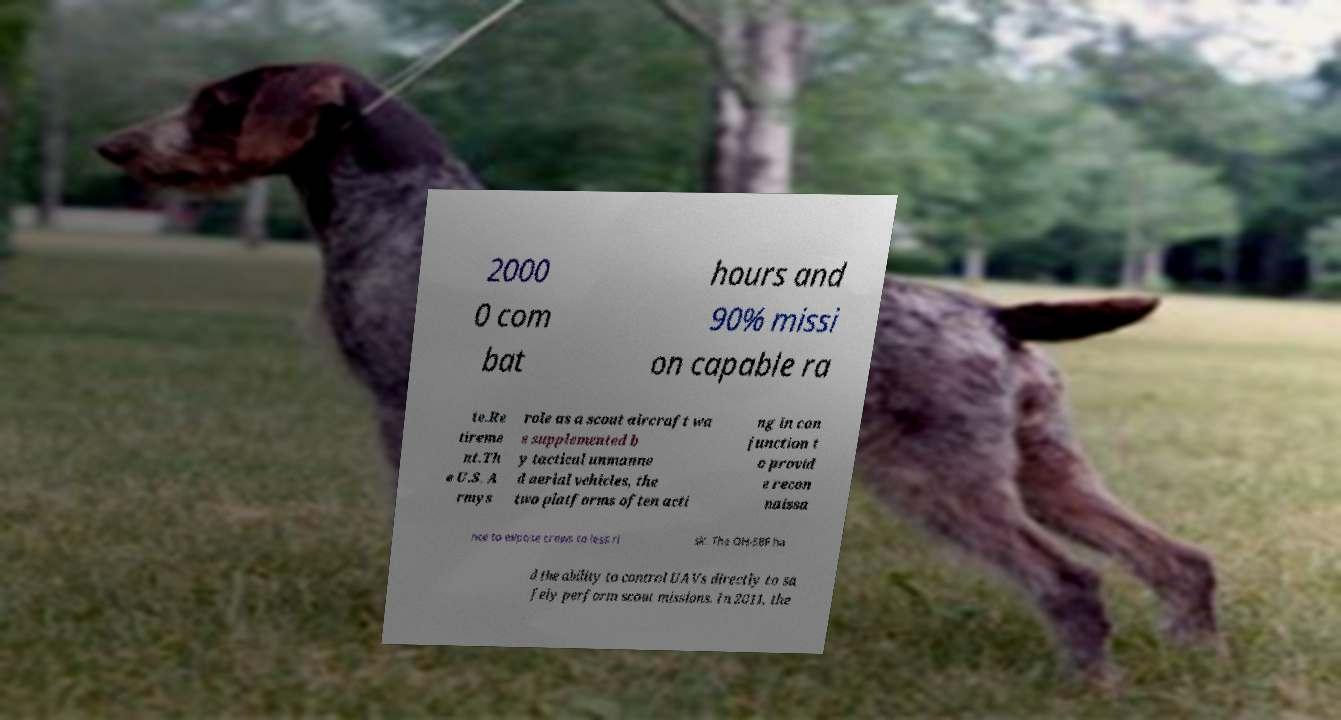Could you extract and type out the text from this image? 2000 0 com bat hours and 90% missi on capable ra te.Re tireme nt.Th e U.S. A rmys role as a scout aircraft wa s supplemented b y tactical unmanne d aerial vehicles, the two platforms often acti ng in con junction t o provid e recon naissa nce to expose crews to less ri sk. The OH-58F ha d the ability to control UAVs directly to sa fely perform scout missions. In 2011, the 